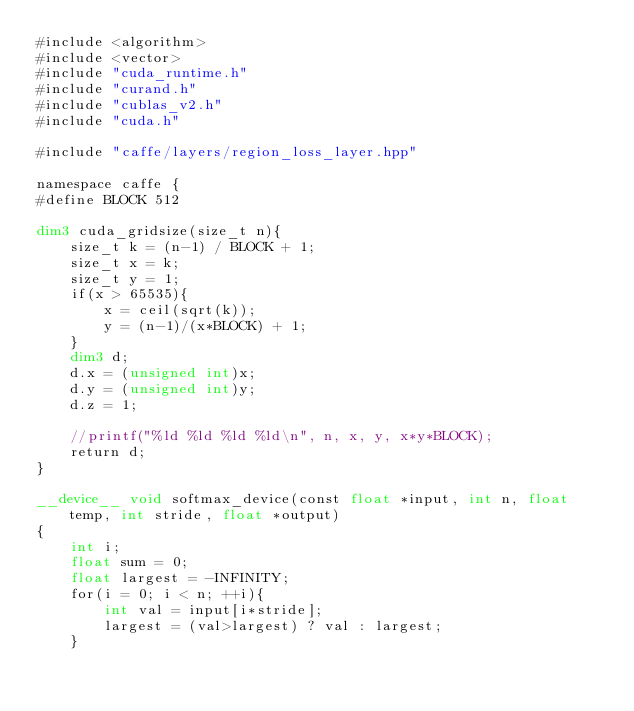<code> <loc_0><loc_0><loc_500><loc_500><_Cuda_>#include <algorithm>
#include <vector>
#include "cuda_runtime.h"
#include "curand.h"
#include "cublas_v2.h"
#include "cuda.h"

#include "caffe/layers/region_loss_layer.hpp"

namespace caffe {
#define BLOCK 512

dim3 cuda_gridsize(size_t n){
    size_t k = (n-1) / BLOCK + 1;
    size_t x = k;
    size_t y = 1;
    if(x > 65535){
        x = ceil(sqrt(k));
        y = (n-1)/(x*BLOCK) + 1;
    }
    dim3 d;
    d.x = (unsigned int)x;
    d.y = (unsigned int)y;
    d.z = 1;

    //printf("%ld %ld %ld %ld\n", n, x, y, x*y*BLOCK);
    return d;
}

__device__ void softmax_device(const float *input, int n, float temp, int stride, float *output)
{
    int i;
    float sum = 0;
    float largest = -INFINITY;
    for(i = 0; i < n; ++i){
        int val = input[i*stride];
        largest = (val>largest) ? val : largest;
    }</code> 